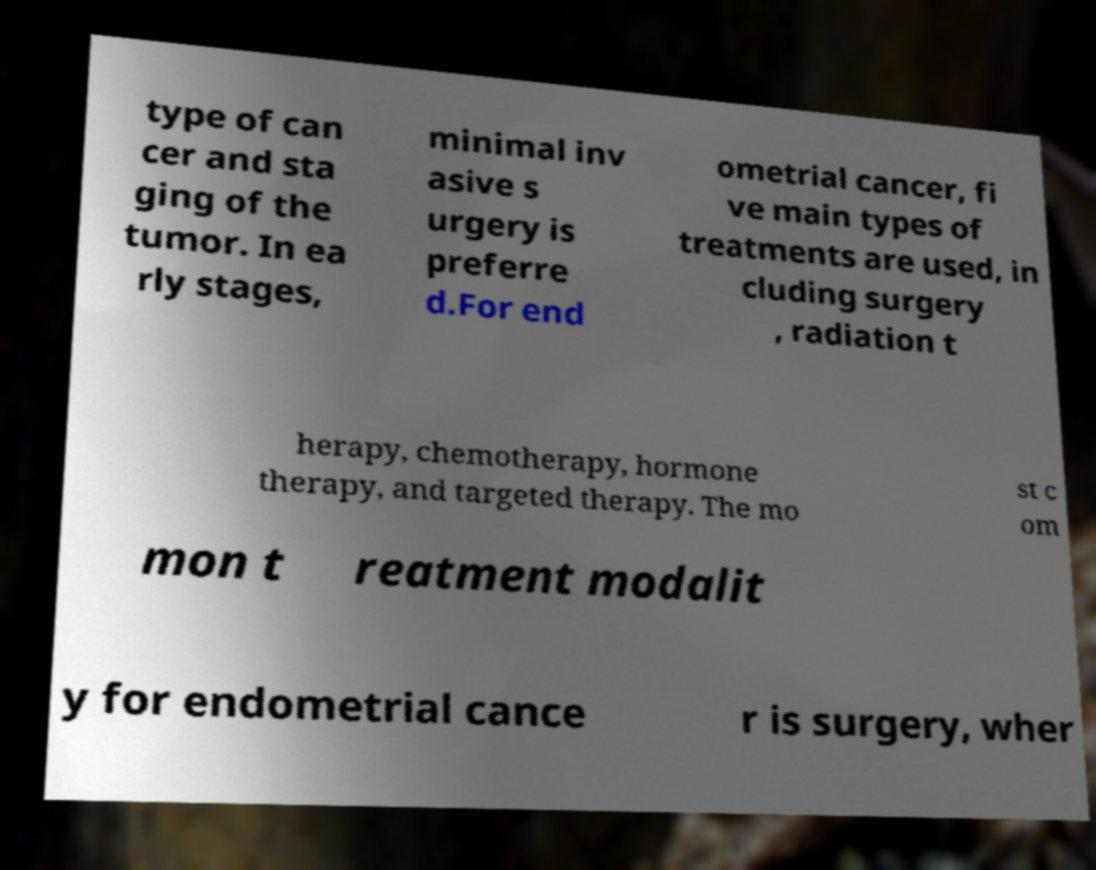There's text embedded in this image that I need extracted. Can you transcribe it verbatim? type of can cer and sta ging of the tumor. In ea rly stages, minimal inv asive s urgery is preferre d.For end ometrial cancer, fi ve main types of treatments are used, in cluding surgery , radiation t herapy, chemotherapy, hormone therapy, and targeted therapy. The mo st c om mon t reatment modalit y for endometrial cance r is surgery, wher 